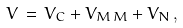Convert formula to latex. <formula><loc_0><loc_0><loc_500><loc_500>V \, = \, V _ { C } + V _ { M \, M } + V _ { N } \, ,</formula> 